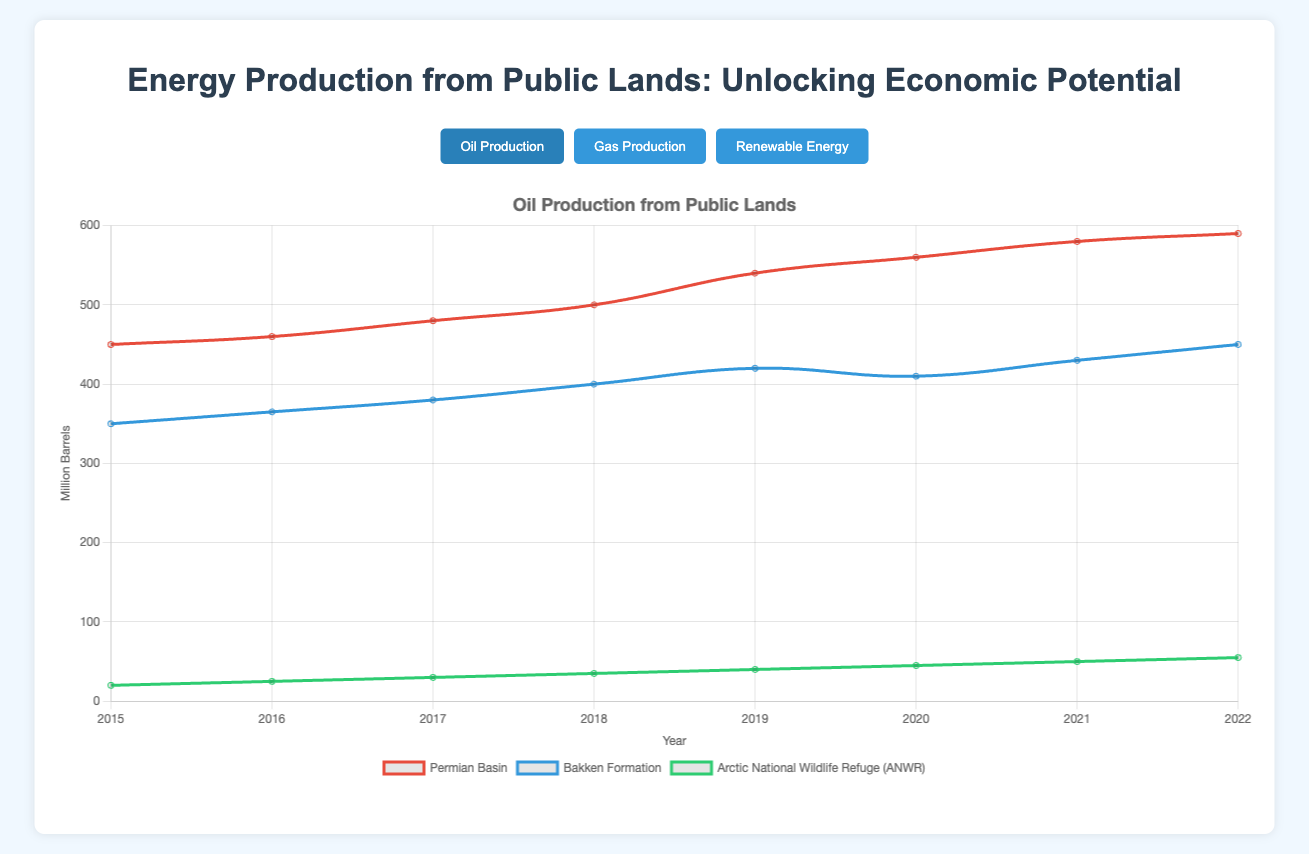What is the trend of oil production in the Arctic National Wildlife Refuge (ANWR) from 2015 to 2022? Looking at the line representing the Arctic National Wildlife Refuge (ANWR), we see a steady increase in oil production every year from 20 million barrels in 2015 to 55 million barrels in 2022.
Answer: Steady increase How does the natural gas production trend in Marcellus Shale compare with Haynesville Shale from 2015 to 2022? Marcellus Shale shows a consistent increase in natural gas production from 2000 billion cubic feet in 2015 to 2800 billion cubic feet in 2022 whereas Haynesville Shale has a slower increase from 1400 in 2015 to 1650 in 2022 with a slight dip around 2020.
Answer: Marcellus Shale increased consistently, Haynesville Shale had a slower increase with a dip in 2020 Which renewable energy source has shown the highest production increase between 2015 and 2022? Bonneville Power Administration Hydro consistently produced the highest energy, going from 4000 GWh in 2015 to 4700 GWh in 2022. However, Mojave Desert Solar has had the highest production increase, starting at 500 GWh in 2015 and rising to 1150 GWh in 2022, showing a production increase of 650 GWh.
Answer: Mojave Desert Solar Between 2018 and 2021, did the oil production in Permian Basin increase or decrease, and by how much? In 2018, the oil production in Permian Basin was 500 million barrels, and by 2021, it increased to 580 million barrels. The production increased by 80 million barrels.
Answer: Increase by 80 million barrels What is the average yearly production of natural gas in the Pinedale Anticline from 2015 to 2022? The production values for Pinedale Anticline are 900, 950, 1000, 1050, 1100, 1150, 1200, and 1250 billion cubic feet. Summing these values gives 9600, and dividing by 8 years gives an average of 1200 billion cubic feet.
Answer: 1200 billion cubic feet Which energy production type has the lowest production value in any given year, and what is that value? Reviewing the data, oil production in Arctic National Wildlife Refuge (ANWR) had the lowest value, starting at 20 million barrels in 2015.
Answer: 20 million barrels (ANWR) in 2015 During which year did the Thunder Ranch Wind reach a production of 600 GWh? Observing the Thunder Ranch Wind plot, it reached 600 GWh in the year 2021.
Answer: 2021 Compare the production rates of Bakken Formation and the Haynesville Shale in 2020. Which one produced more and by how much? In 2020, Bakken Formation's oil production was 410 million barrels, and Haynesville Shale's gas production was 1550 billion cubic feet. Comparing these, Haynesville Shale produced 1140 more units assuming the unit of measure doesn't impact the comparison purpose.
Answer: Haynesville Shale by 1140 units 